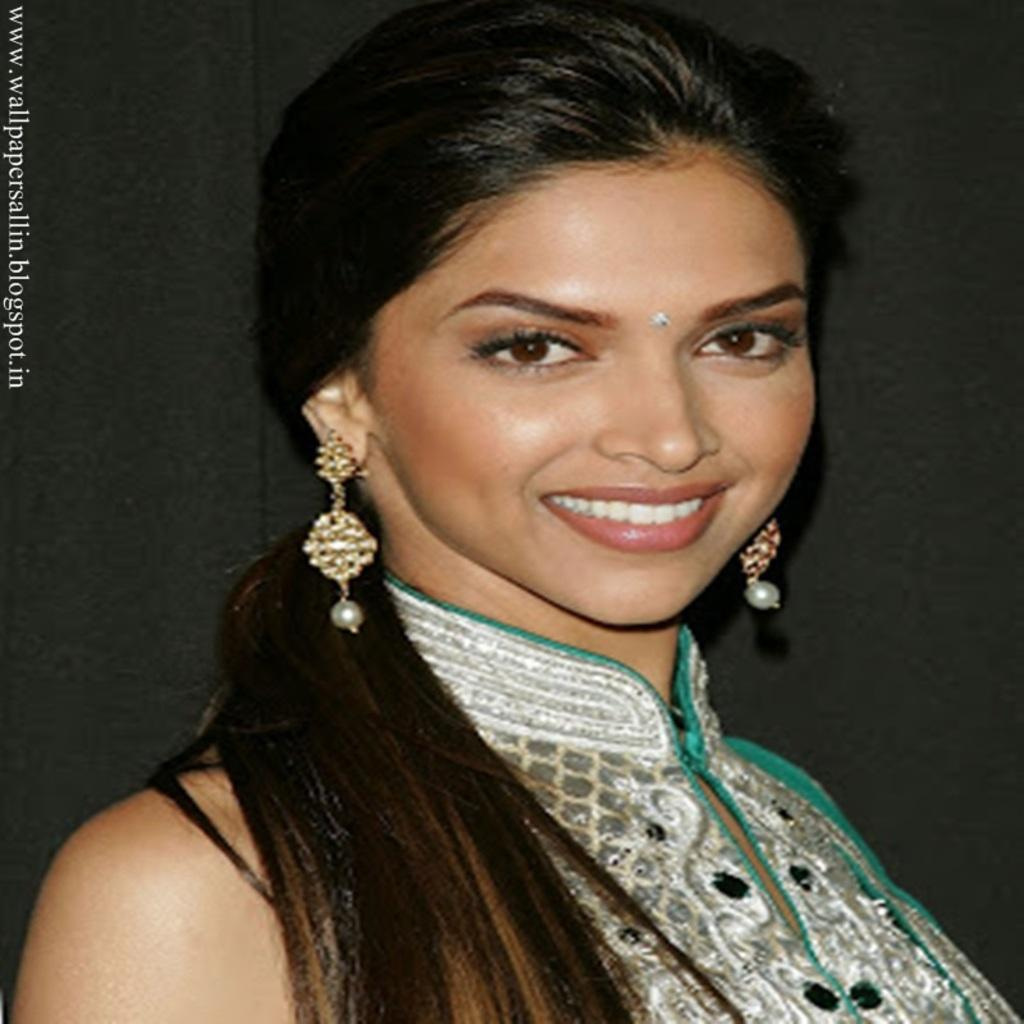Who is the main subject in the image? There is a woman in the image. What is the woman wearing? The woman is wearing a dress and jewelry. Can you describe the woman's hair? The woman has long hair. What type of van can be seen parked next to the woman in the image? There is no van present in the image; it only features a woman. What kind of nut is the woman holding in her hand in the image? There is no nut visible in the image; the woman is not holding anything. 